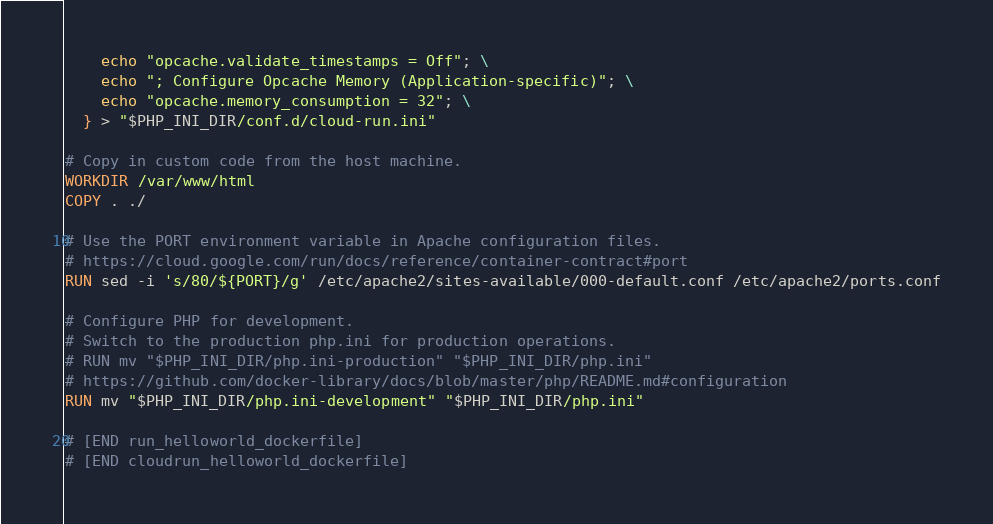Convert code to text. <code><loc_0><loc_0><loc_500><loc_500><_Dockerfile_>    echo "opcache.validate_timestamps = Off"; \
    echo "; Configure Opcache Memory (Application-specific)"; \
    echo "opcache.memory_consumption = 32"; \
  } > "$PHP_INI_DIR/conf.d/cloud-run.ini"

# Copy in custom code from the host machine.
WORKDIR /var/www/html
COPY . ./

# Use the PORT environment variable in Apache configuration files.
# https://cloud.google.com/run/docs/reference/container-contract#port
RUN sed -i 's/80/${PORT}/g' /etc/apache2/sites-available/000-default.conf /etc/apache2/ports.conf

# Configure PHP for development.
# Switch to the production php.ini for production operations.
# RUN mv "$PHP_INI_DIR/php.ini-production" "$PHP_INI_DIR/php.ini"
# https://github.com/docker-library/docs/blob/master/php/README.md#configuration
RUN mv "$PHP_INI_DIR/php.ini-development" "$PHP_INI_DIR/php.ini"

# [END run_helloworld_dockerfile]
# [END cloudrun_helloworld_dockerfile]
</code> 